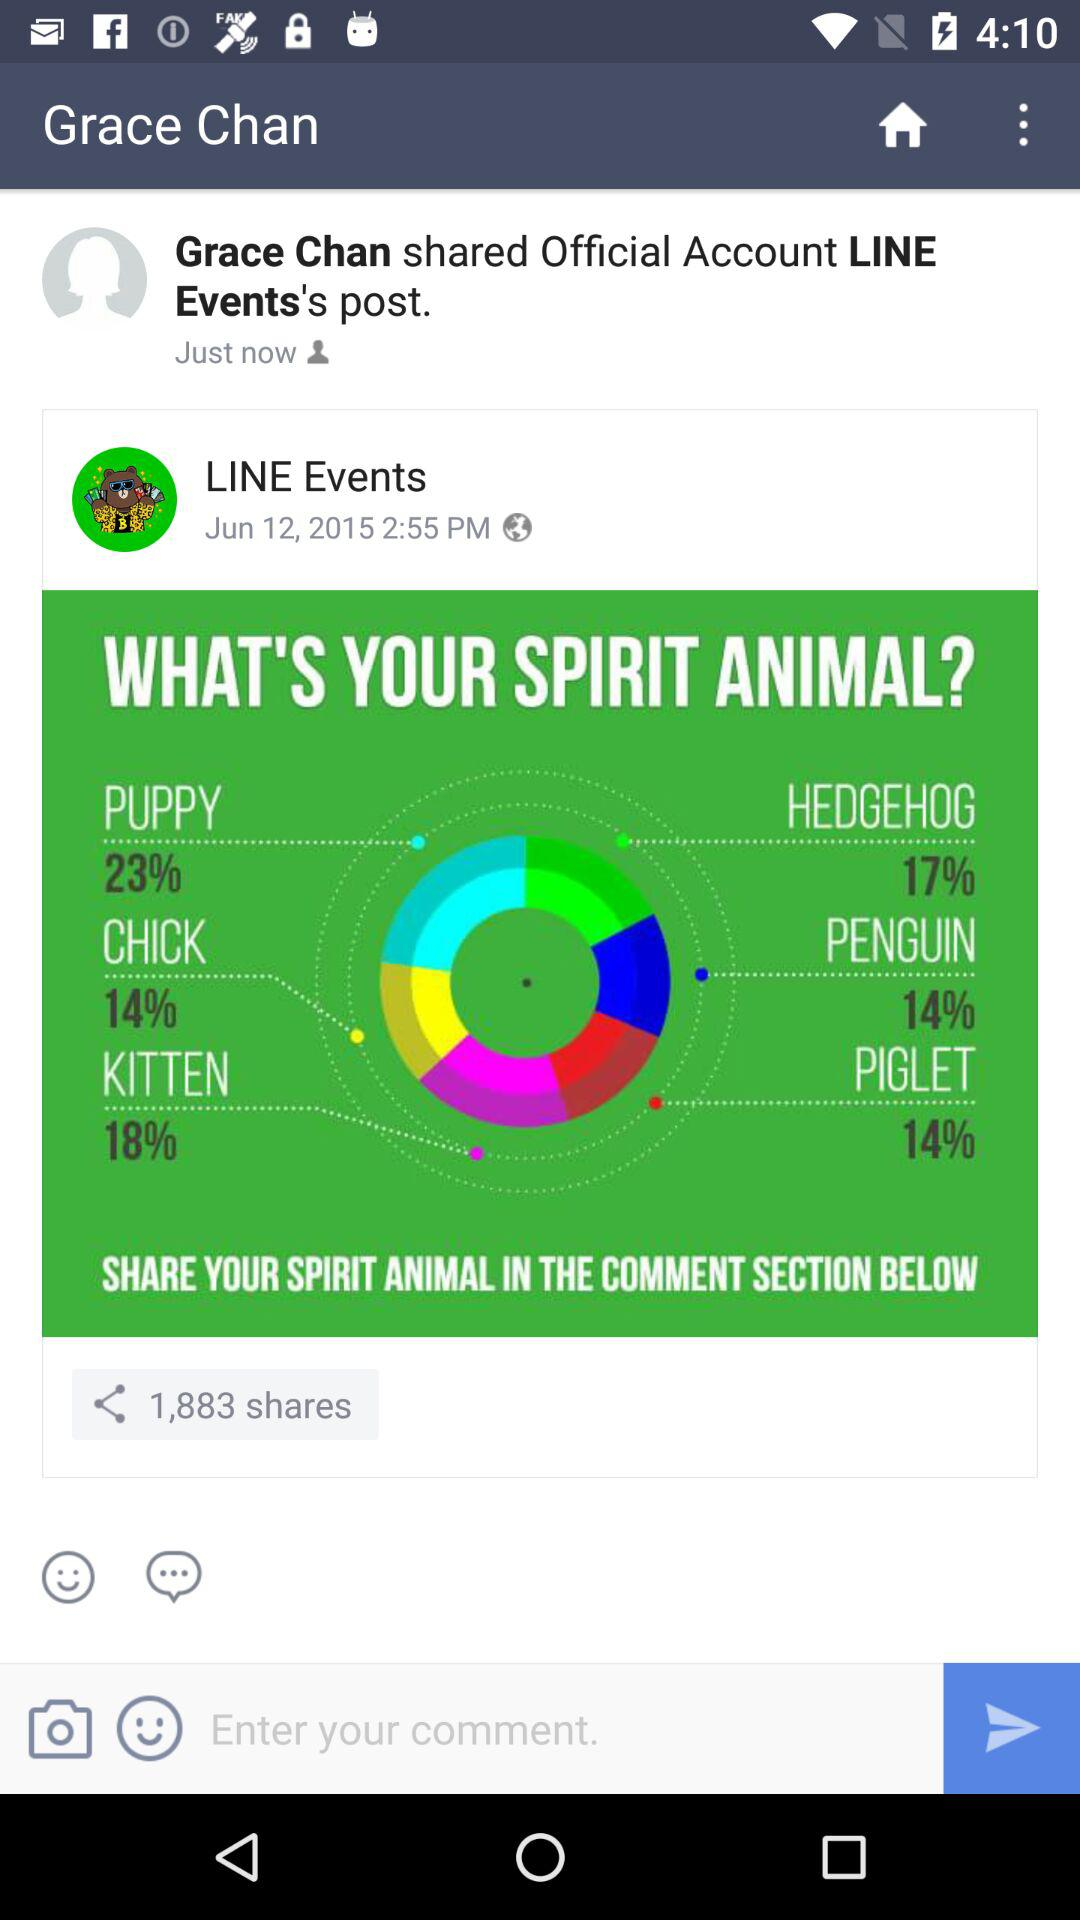How much of the percentage is consumed by "KITTEN"? The consumed percentage is 18. 